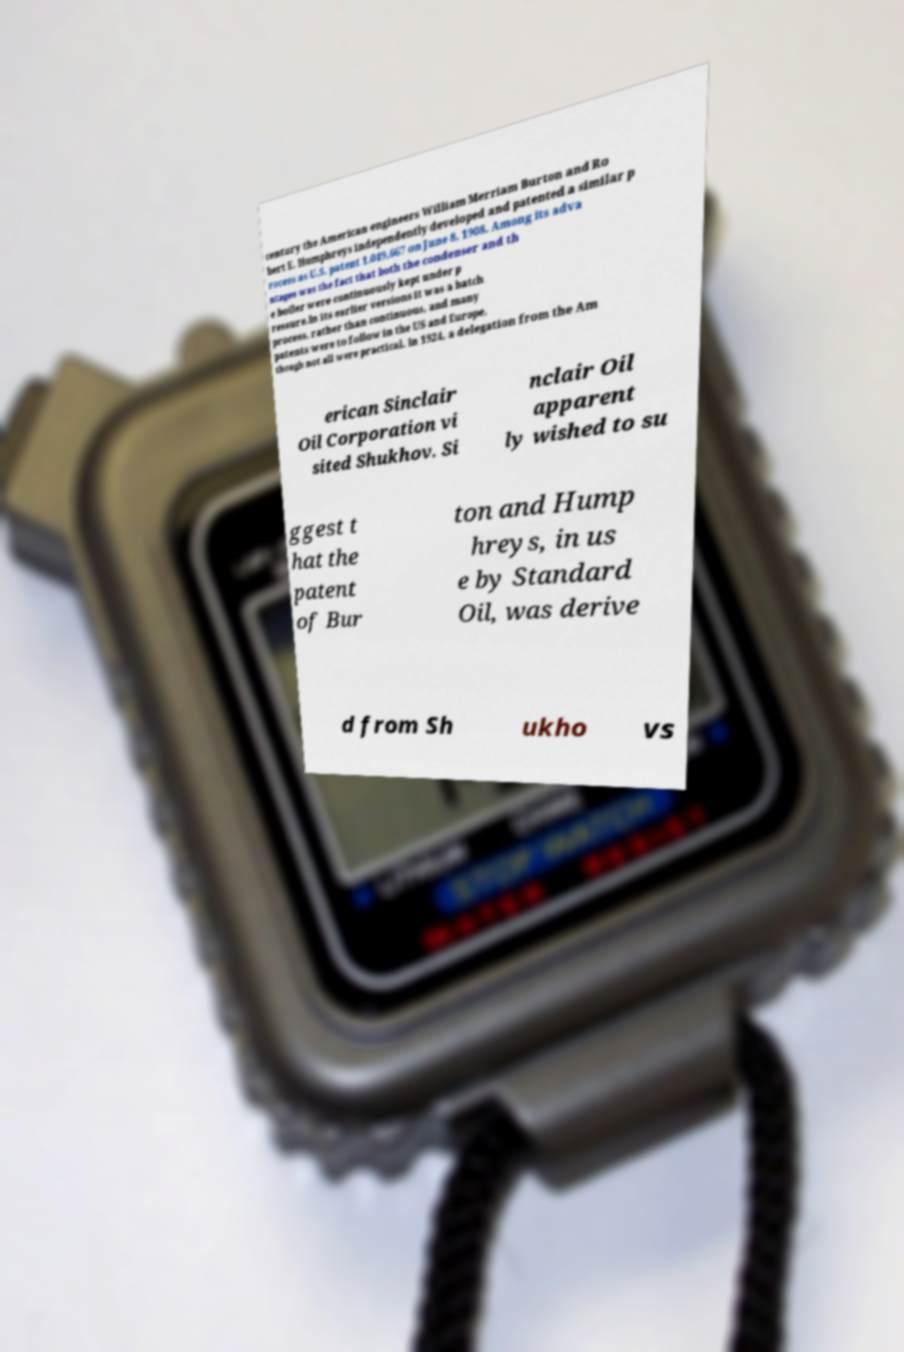Please read and relay the text visible in this image. What does it say? century the American engineers William Merriam Burton and Ro bert E. Humphreys independently developed and patented a similar p rocess as U.S. patent 1,049,667 on June 8, 1908. Among its adva ntages was the fact that both the condenser and th e boiler were continuously kept under p ressure.In its earlier versions it was a batch process, rather than continuous, and many patents were to follow in the US and Europe, though not all were practical. In 1924, a delegation from the Am erican Sinclair Oil Corporation vi sited Shukhov. Si nclair Oil apparent ly wished to su ggest t hat the patent of Bur ton and Hump hreys, in us e by Standard Oil, was derive d from Sh ukho vs 